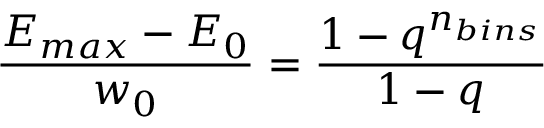<formula> <loc_0><loc_0><loc_500><loc_500>\frac { E _ { \max } - E _ { 0 } } { w _ { 0 } } = \frac { 1 - q ^ { n _ { b i n s } } } { 1 - q }</formula> 